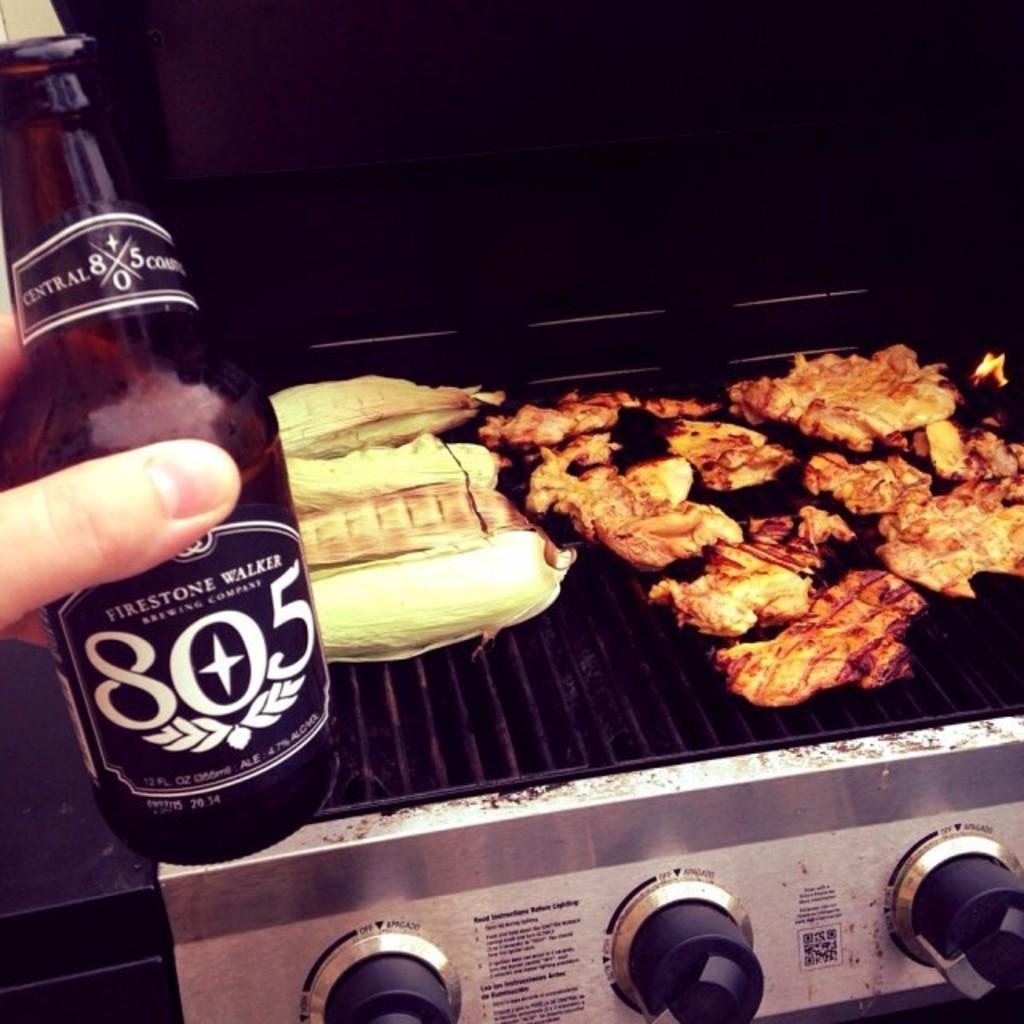<image>
Write a terse but informative summary of the picture. Firestone Walker 805 beer will go with the food on the grill. 